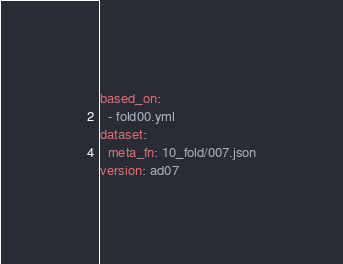<code> <loc_0><loc_0><loc_500><loc_500><_YAML_>based_on:
  - fold00.yml
dataset:
  meta_fn: 10_fold/007.json
version: ad07
</code> 